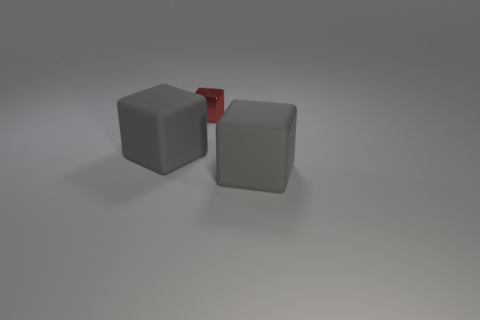Subtract all red metallic cubes. How many cubes are left? 2 Subtract all blue spheres. How many gray cubes are left? 2 Add 3 tiny red metal objects. How many objects exist? 6 Subtract all cyan cubes. Subtract all brown spheres. How many cubes are left? 3 Add 3 small things. How many small things exist? 4 Subtract 0 green balls. How many objects are left? 3 Subtract all red cubes. Subtract all tiny things. How many objects are left? 1 Add 2 red metal things. How many red metal things are left? 3 